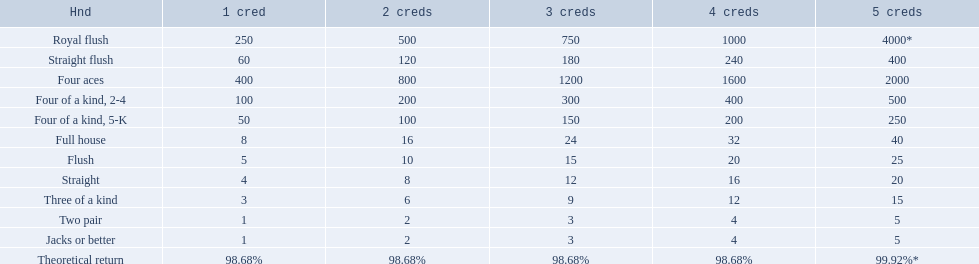What are the different hands? Royal flush, Straight flush, Four aces, Four of a kind, 2-4, Four of a kind, 5-K, Full house, Flush, Straight, Three of a kind, Two pair, Jacks or better. Which hands have a higher standing than a straight? Royal flush, Straight flush, Four aces, Four of a kind, 2-4, Four of a kind, 5-K, Full house, Flush. Of these, which hand is the next highest after a straight? Flush. 